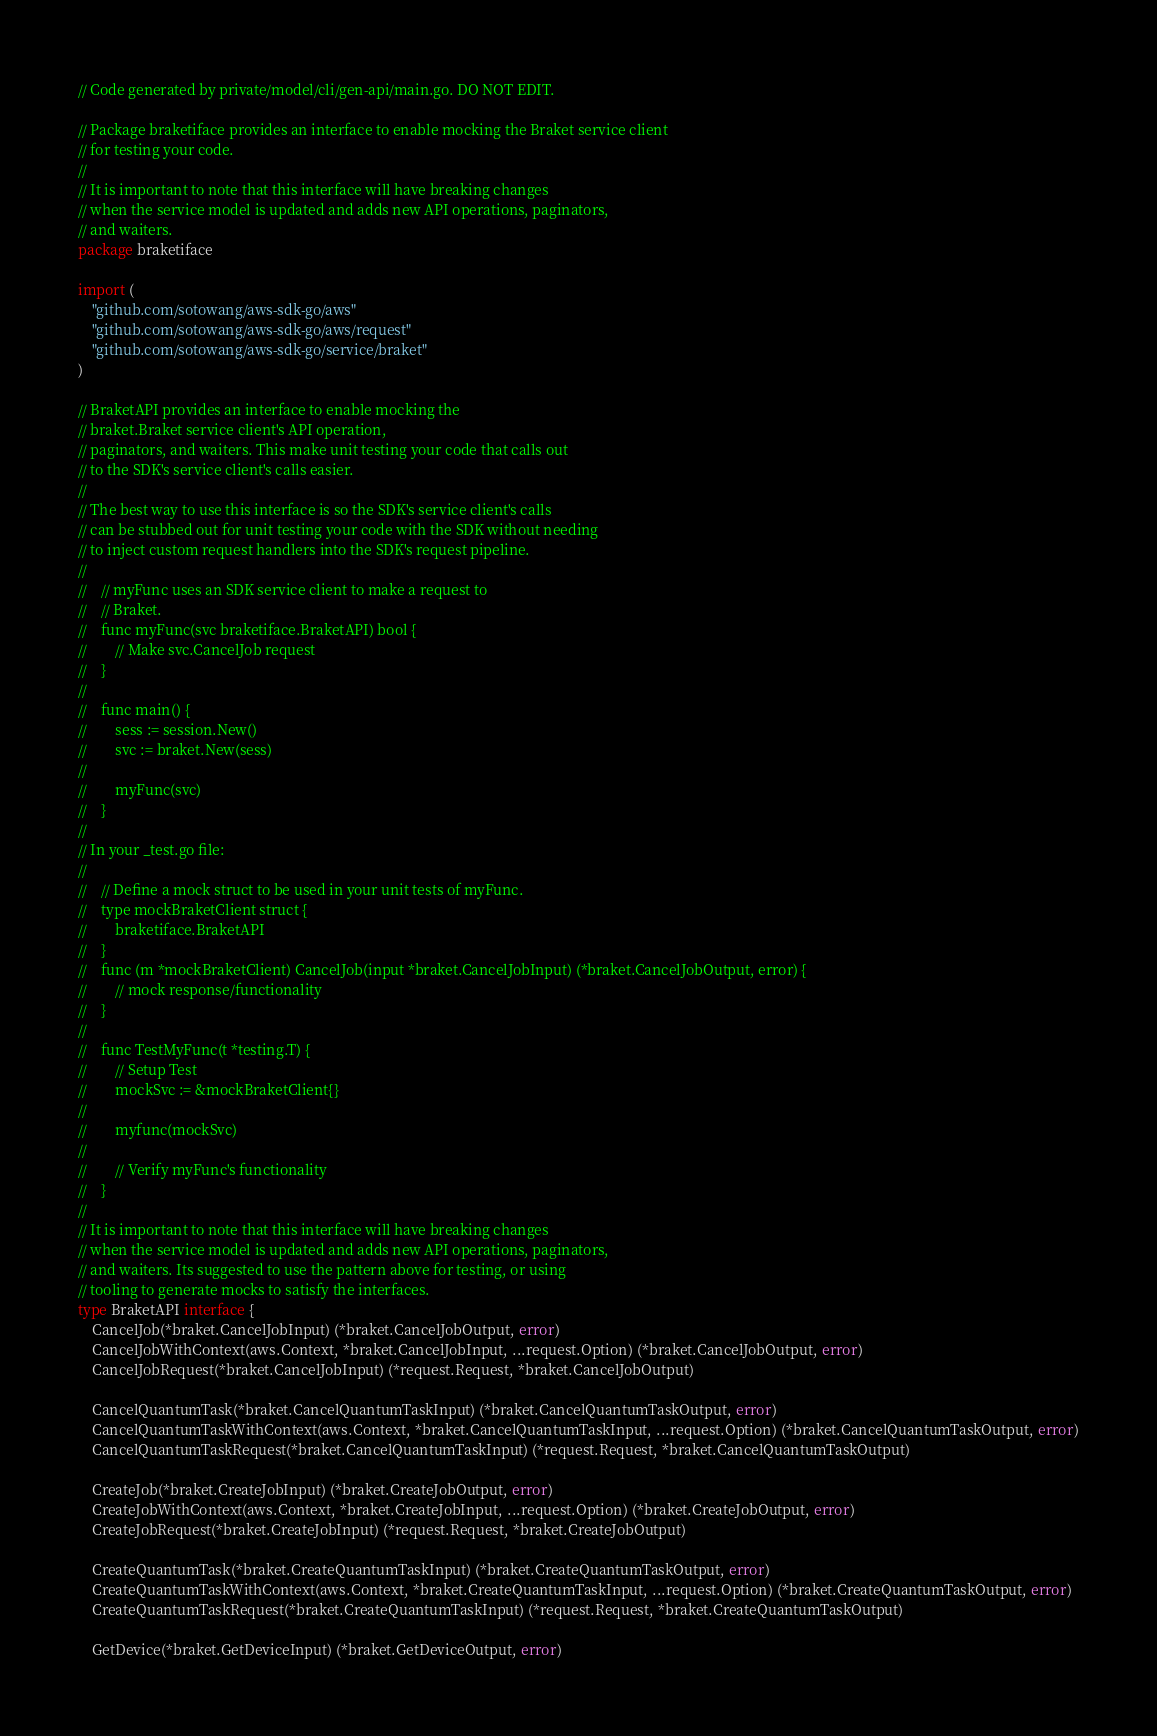Convert code to text. <code><loc_0><loc_0><loc_500><loc_500><_Go_>// Code generated by private/model/cli/gen-api/main.go. DO NOT EDIT.

// Package braketiface provides an interface to enable mocking the Braket service client
// for testing your code.
//
// It is important to note that this interface will have breaking changes
// when the service model is updated and adds new API operations, paginators,
// and waiters.
package braketiface

import (
	"github.com/sotowang/aws-sdk-go/aws"
	"github.com/sotowang/aws-sdk-go/aws/request"
	"github.com/sotowang/aws-sdk-go/service/braket"
)

// BraketAPI provides an interface to enable mocking the
// braket.Braket service client's API operation,
// paginators, and waiters. This make unit testing your code that calls out
// to the SDK's service client's calls easier.
//
// The best way to use this interface is so the SDK's service client's calls
// can be stubbed out for unit testing your code with the SDK without needing
// to inject custom request handlers into the SDK's request pipeline.
//
//    // myFunc uses an SDK service client to make a request to
//    // Braket.
//    func myFunc(svc braketiface.BraketAPI) bool {
//        // Make svc.CancelJob request
//    }
//
//    func main() {
//        sess := session.New()
//        svc := braket.New(sess)
//
//        myFunc(svc)
//    }
//
// In your _test.go file:
//
//    // Define a mock struct to be used in your unit tests of myFunc.
//    type mockBraketClient struct {
//        braketiface.BraketAPI
//    }
//    func (m *mockBraketClient) CancelJob(input *braket.CancelJobInput) (*braket.CancelJobOutput, error) {
//        // mock response/functionality
//    }
//
//    func TestMyFunc(t *testing.T) {
//        // Setup Test
//        mockSvc := &mockBraketClient{}
//
//        myfunc(mockSvc)
//
//        // Verify myFunc's functionality
//    }
//
// It is important to note that this interface will have breaking changes
// when the service model is updated and adds new API operations, paginators,
// and waiters. Its suggested to use the pattern above for testing, or using
// tooling to generate mocks to satisfy the interfaces.
type BraketAPI interface {
	CancelJob(*braket.CancelJobInput) (*braket.CancelJobOutput, error)
	CancelJobWithContext(aws.Context, *braket.CancelJobInput, ...request.Option) (*braket.CancelJobOutput, error)
	CancelJobRequest(*braket.CancelJobInput) (*request.Request, *braket.CancelJobOutput)

	CancelQuantumTask(*braket.CancelQuantumTaskInput) (*braket.CancelQuantumTaskOutput, error)
	CancelQuantumTaskWithContext(aws.Context, *braket.CancelQuantumTaskInput, ...request.Option) (*braket.CancelQuantumTaskOutput, error)
	CancelQuantumTaskRequest(*braket.CancelQuantumTaskInput) (*request.Request, *braket.CancelQuantumTaskOutput)

	CreateJob(*braket.CreateJobInput) (*braket.CreateJobOutput, error)
	CreateJobWithContext(aws.Context, *braket.CreateJobInput, ...request.Option) (*braket.CreateJobOutput, error)
	CreateJobRequest(*braket.CreateJobInput) (*request.Request, *braket.CreateJobOutput)

	CreateQuantumTask(*braket.CreateQuantumTaskInput) (*braket.CreateQuantumTaskOutput, error)
	CreateQuantumTaskWithContext(aws.Context, *braket.CreateQuantumTaskInput, ...request.Option) (*braket.CreateQuantumTaskOutput, error)
	CreateQuantumTaskRequest(*braket.CreateQuantumTaskInput) (*request.Request, *braket.CreateQuantumTaskOutput)

	GetDevice(*braket.GetDeviceInput) (*braket.GetDeviceOutput, error)</code> 